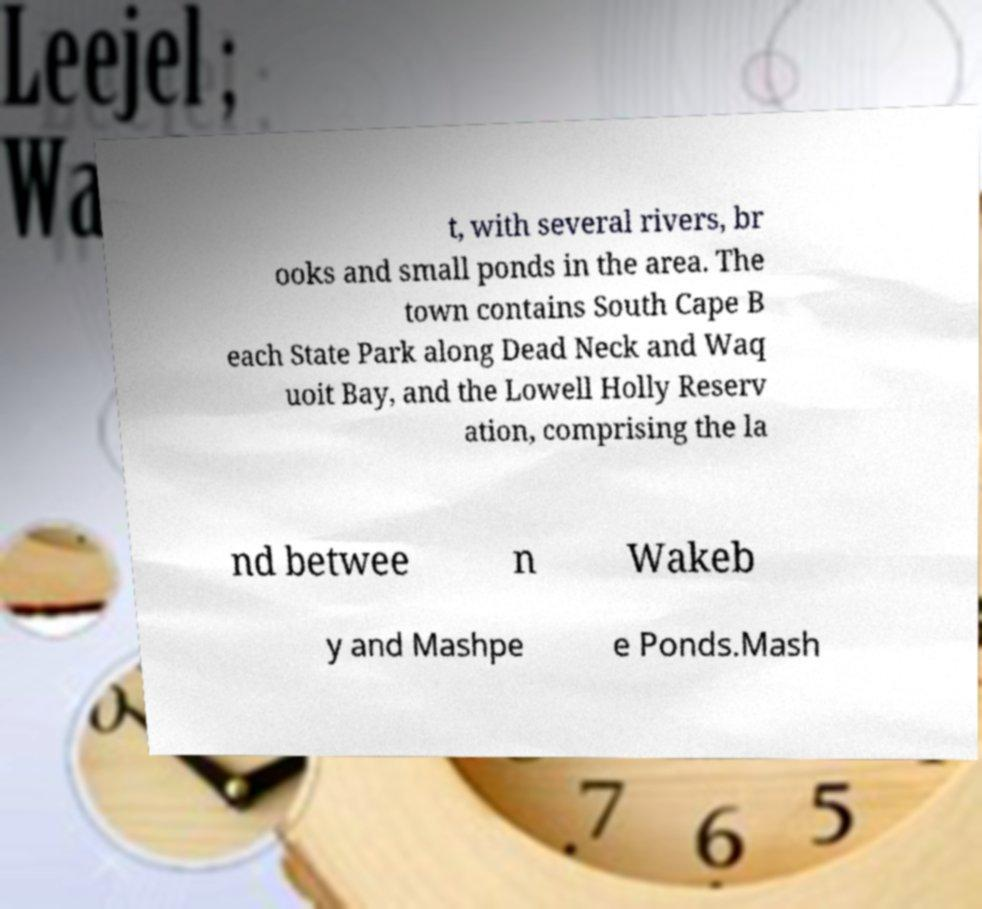Please read and relay the text visible in this image. What does it say? t, with several rivers, br ooks and small ponds in the area. The town contains South Cape B each State Park along Dead Neck and Waq uoit Bay, and the Lowell Holly Reserv ation, comprising the la nd betwee n Wakeb y and Mashpe e Ponds.Mash 